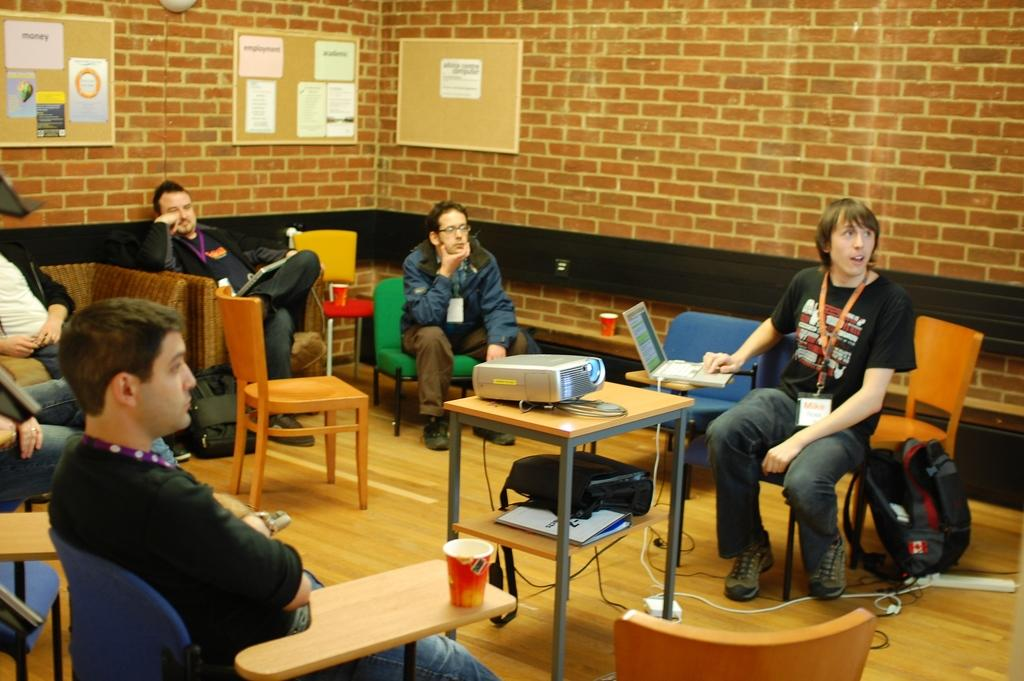What are the people in the image doing? The people in the image are sitting on chairs. What is present on the table in the image? A projector is placed on the table. What might the people be using the projector for? The projector might be used for displaying presentations or videos during a meeting or event. Can you see any dinosaurs in the image? No, there are no dinosaurs present in the image. Are the people's toes visible in the image? The image does not focus on the people's toes, so it is not possible to determine if they are visible. 